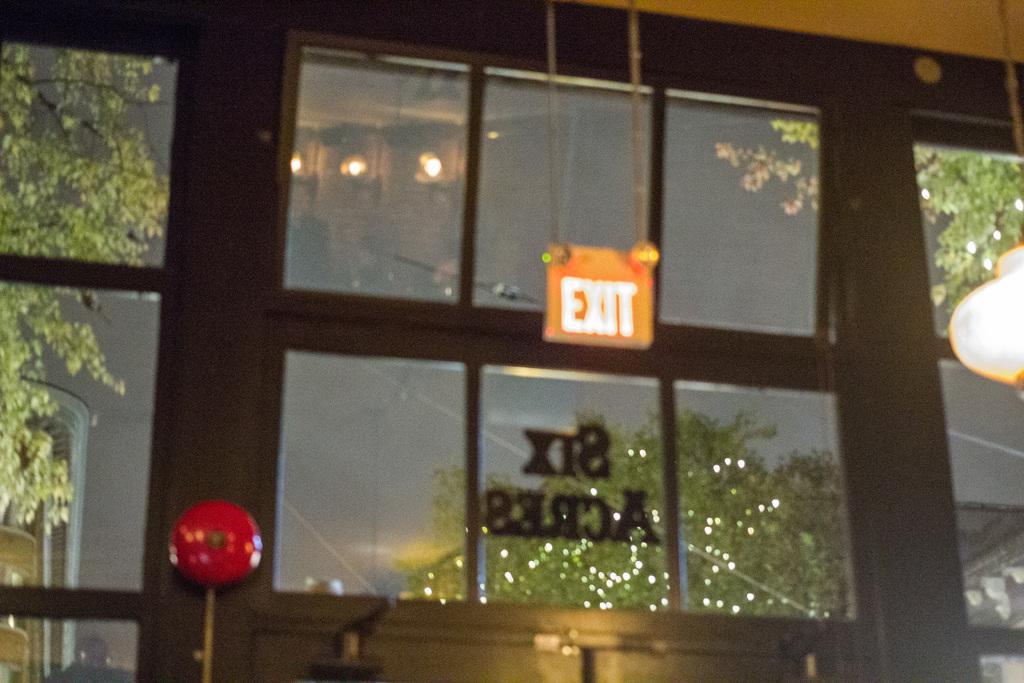Describe this image in one or two sentences. This picture is slightly blurred, where I can exit board, ceiling lights, glass windows through which I can see trees and the dark sky. 